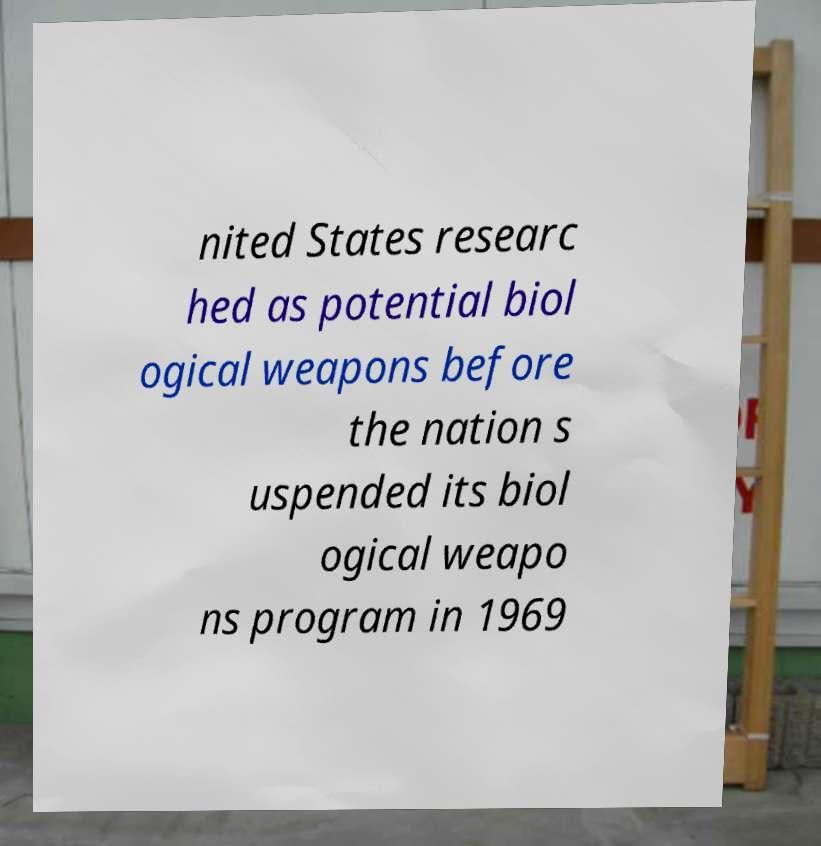Can you accurately transcribe the text from the provided image for me? nited States researc hed as potential biol ogical weapons before the nation s uspended its biol ogical weapo ns program in 1969 